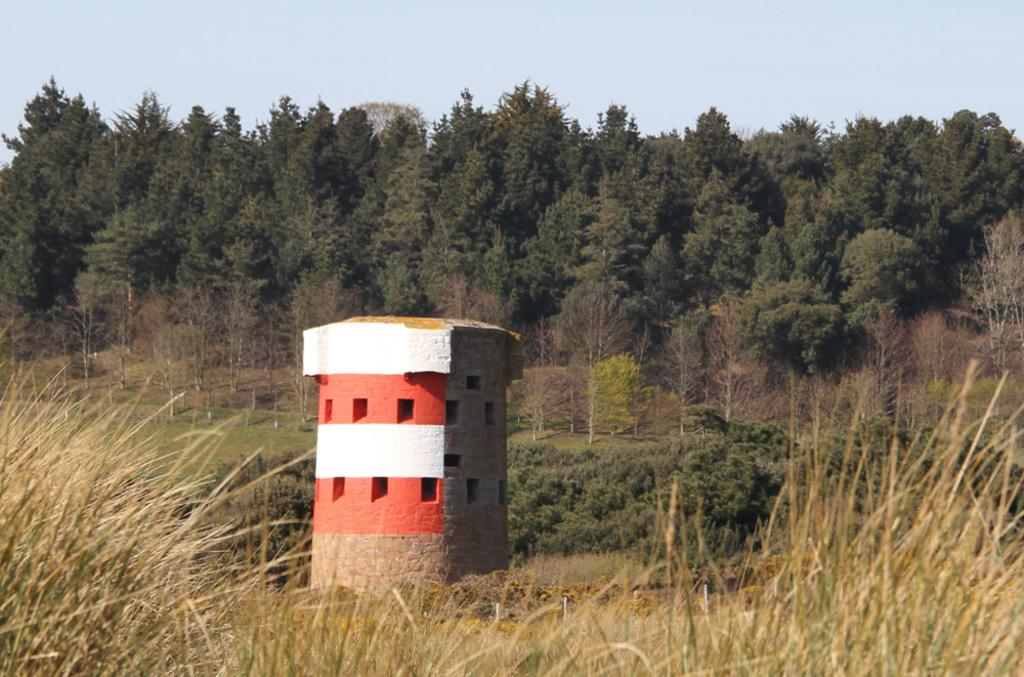What is the main structure in the image? There is there a tower in the image? What features can be seen on the tower? The tower has windows. What type of vegetation is present near the tower? There is grass on the ground near the tower. What other types of vegetation are in the image? There are plants and trees in the image. What can be seen in the background of the image? The sky is blue in the background. Who is the owner of the idea depicted in the image? There is no reference to an idea or ownership in the image; it features a tower with windows, grass, plants, trees, and a blue sky. 